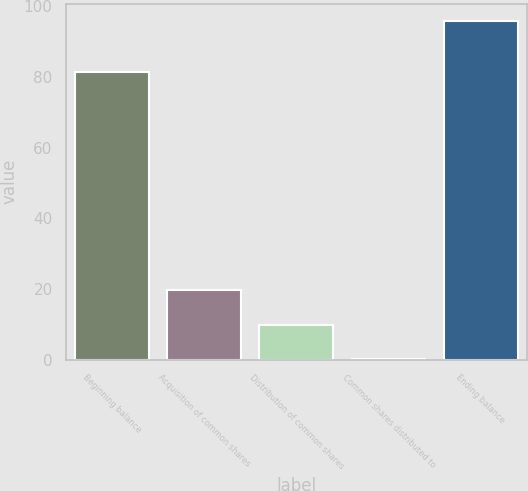Convert chart. <chart><loc_0><loc_0><loc_500><loc_500><bar_chart><fcel>Beginning balance<fcel>Acquisition of common shares<fcel>Distribution of common shares<fcel>Common shares distributed to<fcel>Ending balance<nl><fcel>81.3<fcel>19.6<fcel>9.86<fcel>0.3<fcel>95.9<nl></chart> 